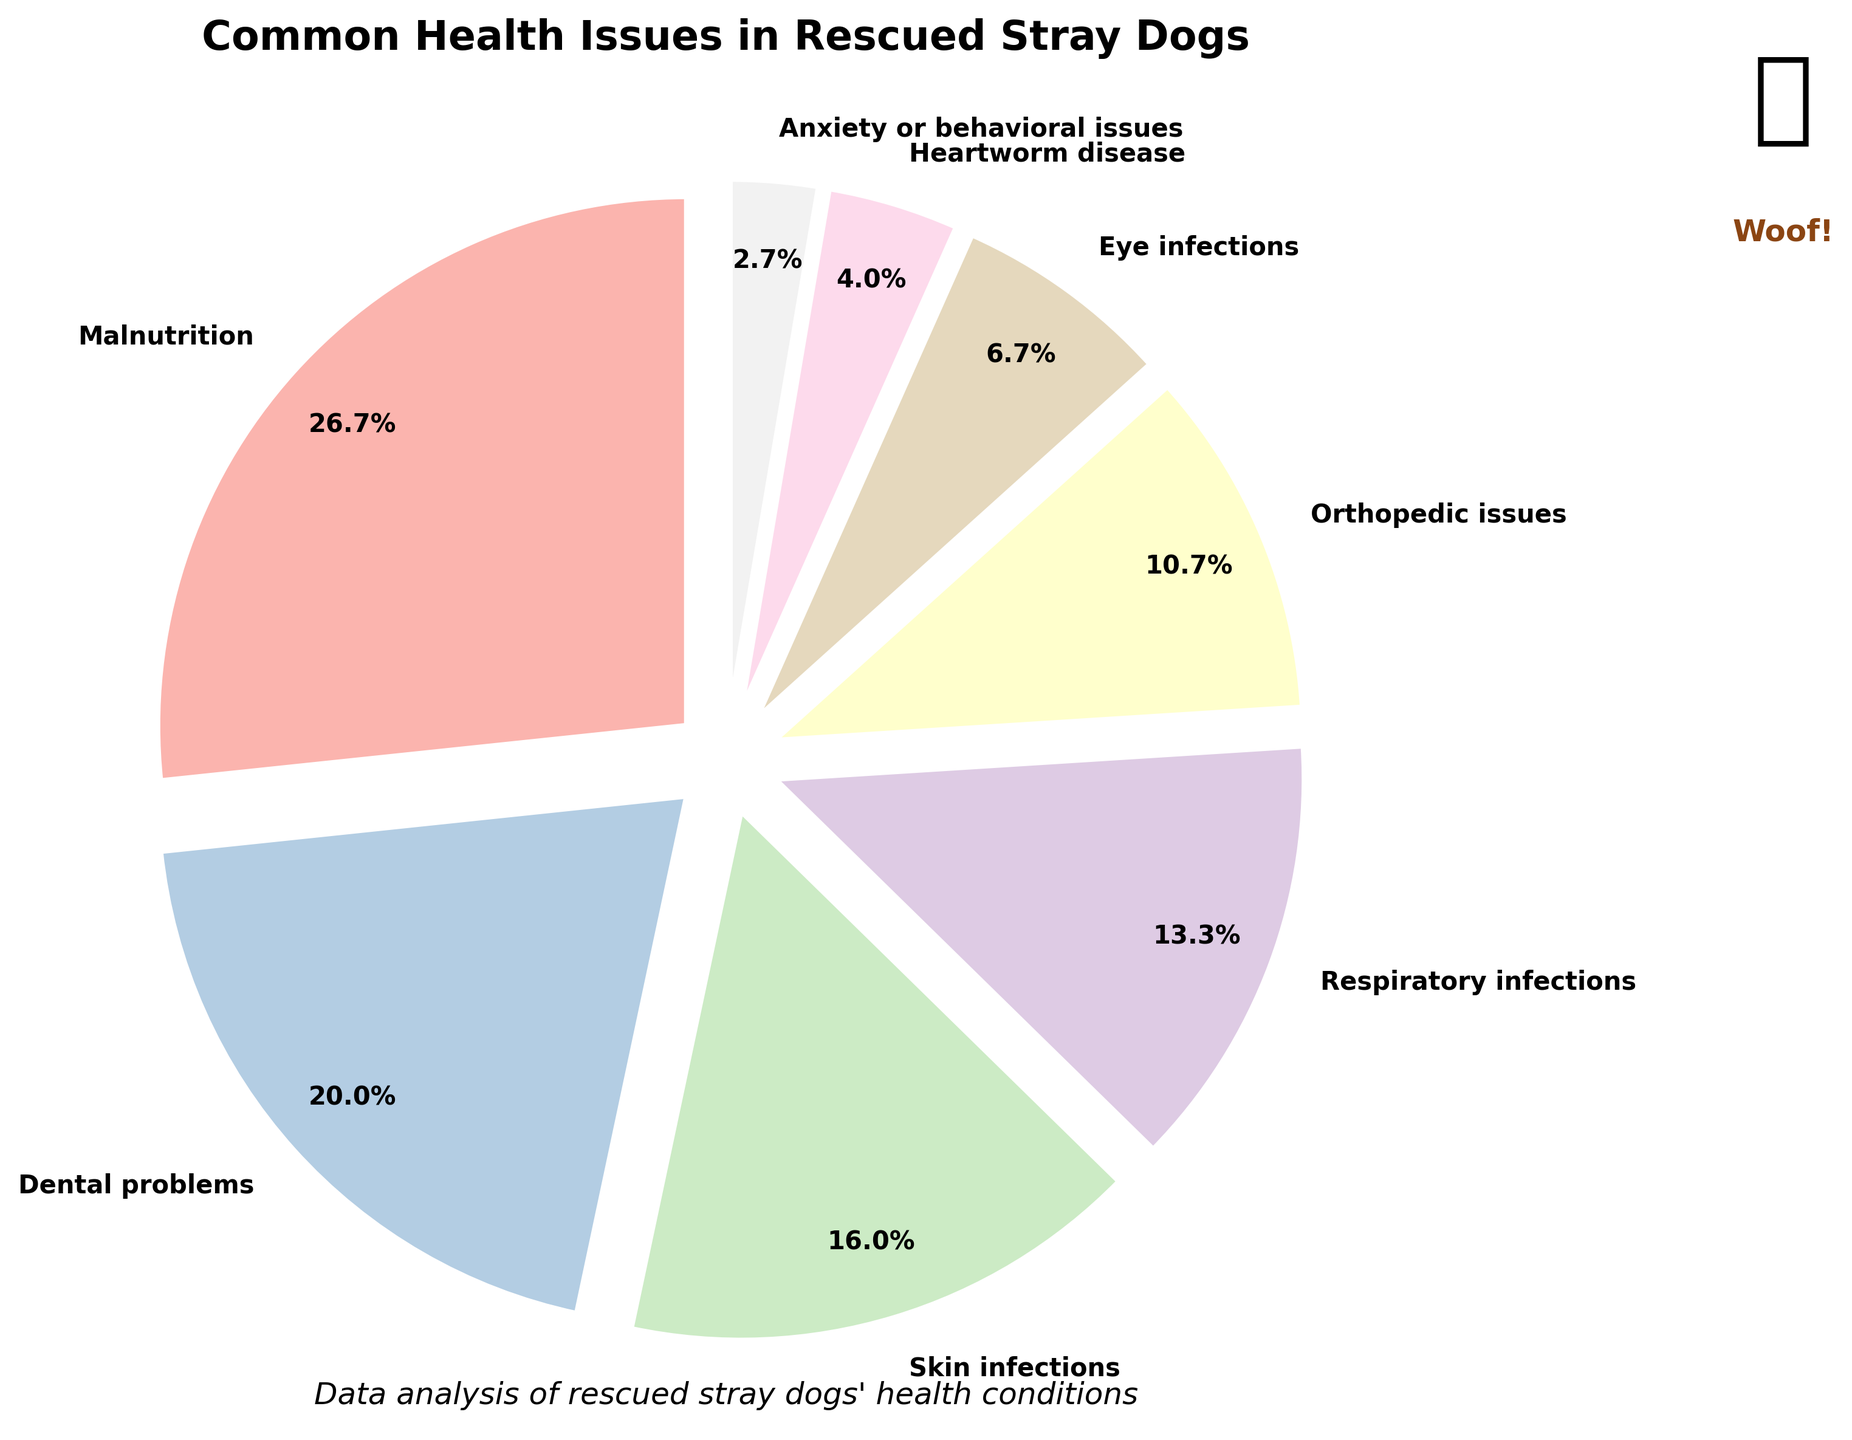What is the most common health issue in rescued stray dogs? According to the pie chart, the largest wedge represents Malnutrition with the highest percentage.
Answer: Malnutrition Which health issue has a percentage closest to that of Dental problems? The chart shows that Dental problems have a percentage of 15%. The closest to this is Skin infections, with 12%.
Answer: Skin infections What is the combined percentage of Orthopedic issues and Respiratory infections? Orthopedic issues have 8%, and Respiratory infections have 10%. Combining these gives 8% + 10% = 18%.
Answer: 18% How does the size of the slice for Eye infections compare to that of Heartworm disease? The slice for Eye infections is 5%, whereas Heartworm disease is less, at 3%.
Answer: Eye infections>Heartworm disease Which health issue has the smallest percentage, and what is it? The smallest slice on the pie chart represents Anxiety or behavioral issues with a percentage of 2%.
Answer: Anxiety or behavioral issues, 2% Is the percentage of Malnutrition more than double the percentage of Orthopedic issues? Malnutrition is 20% and Orthopedic issues are 8%. Doubling 8% gives 16%, which is less than 20%. So, yes, 20% is more than double 8%.
Answer: Yes What is the total percentage of non-infectious health issues (sum of Malnutrition, Orthopedic issues, Heartworm disease, and Anxiety or behavioral issues)? Summing up Malnutrition (20%), Orthopedic issues (8%), Heartworm disease (3%), and Anxiety or behavioral issues (2%) gives 20% + 8% + 3% + 2% = 33%.
Answer: 33% By how much is the percentage of Malnutrition greater than Dental problems? The percentage for Malnutrition is 20% and for Dental problems is 15%. The difference is 20% - 15% = 5%.
Answer: 5% What's the ratio of the percentage of Respiratory infections to Eye infections? The percentage for Respiratory infections is 10% and for Eye infections is 5%. The ratio is 10% to 5%, which simplifies to 2:1.
Answer: 2:1 Which three health issues together constitute a little over 50% of the cases? Combining Malnutrition (20%), Dental problems (15%), and Skin infections (12%) gives 20% + 15% + 12% = 47%, which is just under 50%. Including Respiratory infections adds 10% for a total of 57% together.
Answer: Malnutrition, Dental problems, and Respiratory infections 